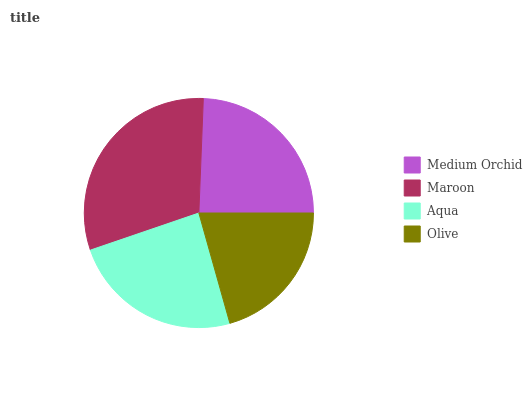Is Olive the minimum?
Answer yes or no. Yes. Is Maroon the maximum?
Answer yes or no. Yes. Is Aqua the minimum?
Answer yes or no. No. Is Aqua the maximum?
Answer yes or no. No. Is Maroon greater than Aqua?
Answer yes or no. Yes. Is Aqua less than Maroon?
Answer yes or no. Yes. Is Aqua greater than Maroon?
Answer yes or no. No. Is Maroon less than Aqua?
Answer yes or no. No. Is Medium Orchid the high median?
Answer yes or no. Yes. Is Aqua the low median?
Answer yes or no. Yes. Is Maroon the high median?
Answer yes or no. No. Is Medium Orchid the low median?
Answer yes or no. No. 